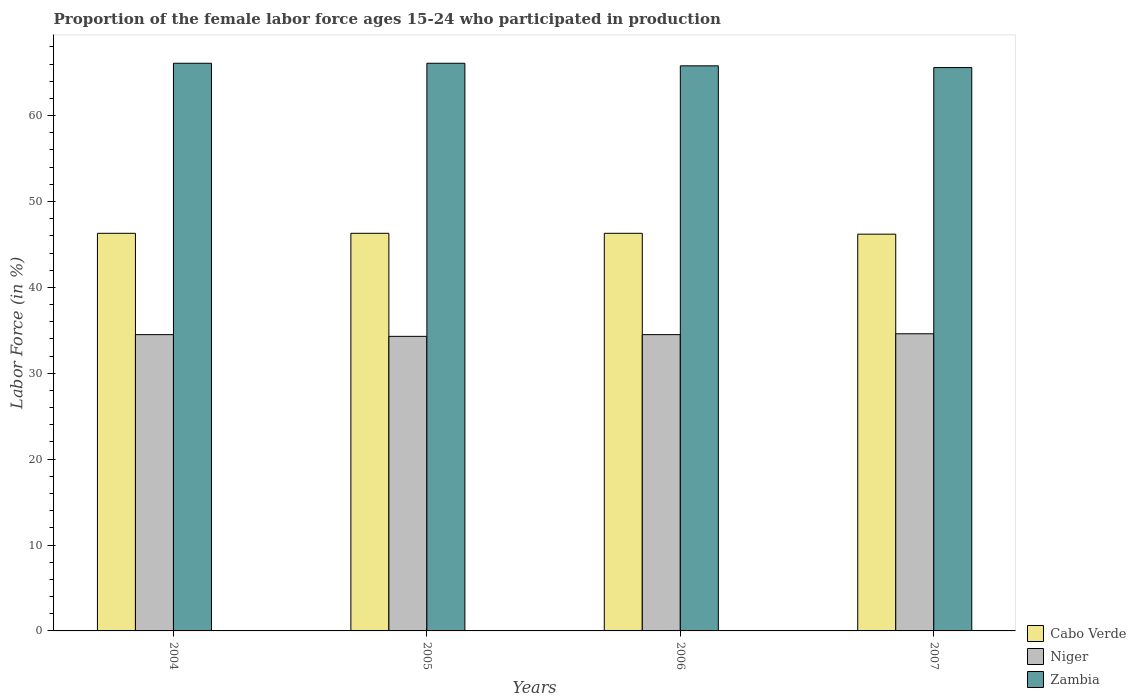How many groups of bars are there?
Ensure brevity in your answer.  4. Are the number of bars per tick equal to the number of legend labels?
Make the answer very short. Yes. Are the number of bars on each tick of the X-axis equal?
Offer a terse response. Yes. How many bars are there on the 2nd tick from the left?
Make the answer very short. 3. What is the label of the 4th group of bars from the left?
Ensure brevity in your answer.  2007. What is the proportion of the female labor force who participated in production in Cabo Verde in 2004?
Your response must be concise. 46.3. Across all years, what is the maximum proportion of the female labor force who participated in production in Niger?
Ensure brevity in your answer.  34.6. Across all years, what is the minimum proportion of the female labor force who participated in production in Niger?
Ensure brevity in your answer.  34.3. What is the total proportion of the female labor force who participated in production in Cabo Verde in the graph?
Offer a terse response. 185.1. What is the difference between the proportion of the female labor force who participated in production in Cabo Verde in 2006 and the proportion of the female labor force who participated in production in Niger in 2004?
Ensure brevity in your answer.  11.8. What is the average proportion of the female labor force who participated in production in Niger per year?
Provide a succinct answer. 34.47. In the year 2006, what is the difference between the proportion of the female labor force who participated in production in Cabo Verde and proportion of the female labor force who participated in production in Zambia?
Make the answer very short. -19.5. What is the difference between the highest and the second highest proportion of the female labor force who participated in production in Zambia?
Keep it short and to the point. 0. What is the difference between the highest and the lowest proportion of the female labor force who participated in production in Zambia?
Provide a succinct answer. 0.5. In how many years, is the proportion of the female labor force who participated in production in Zambia greater than the average proportion of the female labor force who participated in production in Zambia taken over all years?
Offer a very short reply. 2. Is the sum of the proportion of the female labor force who participated in production in Zambia in 2005 and 2007 greater than the maximum proportion of the female labor force who participated in production in Cabo Verde across all years?
Give a very brief answer. Yes. What does the 3rd bar from the left in 2005 represents?
Your answer should be compact. Zambia. What does the 3rd bar from the right in 2005 represents?
Ensure brevity in your answer.  Cabo Verde. Is it the case that in every year, the sum of the proportion of the female labor force who participated in production in Cabo Verde and proportion of the female labor force who participated in production in Niger is greater than the proportion of the female labor force who participated in production in Zambia?
Your response must be concise. Yes. How many bars are there?
Offer a terse response. 12. Are all the bars in the graph horizontal?
Your response must be concise. No. How many years are there in the graph?
Your answer should be compact. 4. Are the values on the major ticks of Y-axis written in scientific E-notation?
Ensure brevity in your answer.  No. Does the graph contain grids?
Your response must be concise. No. How are the legend labels stacked?
Give a very brief answer. Vertical. What is the title of the graph?
Offer a terse response. Proportion of the female labor force ages 15-24 who participated in production. What is the Labor Force (in %) of Cabo Verde in 2004?
Your response must be concise. 46.3. What is the Labor Force (in %) of Niger in 2004?
Make the answer very short. 34.5. What is the Labor Force (in %) in Zambia in 2004?
Ensure brevity in your answer.  66.1. What is the Labor Force (in %) of Cabo Verde in 2005?
Make the answer very short. 46.3. What is the Labor Force (in %) in Niger in 2005?
Make the answer very short. 34.3. What is the Labor Force (in %) of Zambia in 2005?
Provide a succinct answer. 66.1. What is the Labor Force (in %) in Cabo Verde in 2006?
Offer a very short reply. 46.3. What is the Labor Force (in %) of Niger in 2006?
Provide a succinct answer. 34.5. What is the Labor Force (in %) in Zambia in 2006?
Offer a terse response. 65.8. What is the Labor Force (in %) of Cabo Verde in 2007?
Offer a terse response. 46.2. What is the Labor Force (in %) in Niger in 2007?
Make the answer very short. 34.6. What is the Labor Force (in %) in Zambia in 2007?
Provide a succinct answer. 65.6. Across all years, what is the maximum Labor Force (in %) of Cabo Verde?
Make the answer very short. 46.3. Across all years, what is the maximum Labor Force (in %) in Niger?
Give a very brief answer. 34.6. Across all years, what is the maximum Labor Force (in %) of Zambia?
Provide a short and direct response. 66.1. Across all years, what is the minimum Labor Force (in %) of Cabo Verde?
Your response must be concise. 46.2. Across all years, what is the minimum Labor Force (in %) in Niger?
Your answer should be very brief. 34.3. Across all years, what is the minimum Labor Force (in %) in Zambia?
Your answer should be compact. 65.6. What is the total Labor Force (in %) in Cabo Verde in the graph?
Keep it short and to the point. 185.1. What is the total Labor Force (in %) of Niger in the graph?
Provide a succinct answer. 137.9. What is the total Labor Force (in %) in Zambia in the graph?
Provide a short and direct response. 263.6. What is the difference between the Labor Force (in %) of Zambia in 2004 and that in 2005?
Offer a terse response. 0. What is the difference between the Labor Force (in %) of Cabo Verde in 2004 and that in 2006?
Keep it short and to the point. 0. What is the difference between the Labor Force (in %) in Zambia in 2004 and that in 2006?
Your response must be concise. 0.3. What is the difference between the Labor Force (in %) of Cabo Verde in 2004 and that in 2007?
Offer a terse response. 0.1. What is the difference between the Labor Force (in %) in Niger in 2004 and that in 2007?
Your answer should be very brief. -0.1. What is the difference between the Labor Force (in %) of Zambia in 2004 and that in 2007?
Keep it short and to the point. 0.5. What is the difference between the Labor Force (in %) of Cabo Verde in 2005 and that in 2006?
Offer a very short reply. 0. What is the difference between the Labor Force (in %) of Niger in 2005 and that in 2006?
Make the answer very short. -0.2. What is the difference between the Labor Force (in %) in Cabo Verde in 2005 and that in 2007?
Your answer should be very brief. 0.1. What is the difference between the Labor Force (in %) in Zambia in 2006 and that in 2007?
Offer a very short reply. 0.2. What is the difference between the Labor Force (in %) in Cabo Verde in 2004 and the Labor Force (in %) in Niger in 2005?
Keep it short and to the point. 12. What is the difference between the Labor Force (in %) of Cabo Verde in 2004 and the Labor Force (in %) of Zambia in 2005?
Offer a very short reply. -19.8. What is the difference between the Labor Force (in %) in Niger in 2004 and the Labor Force (in %) in Zambia in 2005?
Give a very brief answer. -31.6. What is the difference between the Labor Force (in %) in Cabo Verde in 2004 and the Labor Force (in %) in Niger in 2006?
Your answer should be very brief. 11.8. What is the difference between the Labor Force (in %) in Cabo Verde in 2004 and the Labor Force (in %) in Zambia in 2006?
Provide a short and direct response. -19.5. What is the difference between the Labor Force (in %) of Niger in 2004 and the Labor Force (in %) of Zambia in 2006?
Keep it short and to the point. -31.3. What is the difference between the Labor Force (in %) in Cabo Verde in 2004 and the Labor Force (in %) in Zambia in 2007?
Your response must be concise. -19.3. What is the difference between the Labor Force (in %) in Niger in 2004 and the Labor Force (in %) in Zambia in 2007?
Offer a very short reply. -31.1. What is the difference between the Labor Force (in %) in Cabo Verde in 2005 and the Labor Force (in %) in Zambia in 2006?
Offer a terse response. -19.5. What is the difference between the Labor Force (in %) of Niger in 2005 and the Labor Force (in %) of Zambia in 2006?
Give a very brief answer. -31.5. What is the difference between the Labor Force (in %) of Cabo Verde in 2005 and the Labor Force (in %) of Zambia in 2007?
Give a very brief answer. -19.3. What is the difference between the Labor Force (in %) in Niger in 2005 and the Labor Force (in %) in Zambia in 2007?
Make the answer very short. -31.3. What is the difference between the Labor Force (in %) in Cabo Verde in 2006 and the Labor Force (in %) in Niger in 2007?
Give a very brief answer. 11.7. What is the difference between the Labor Force (in %) of Cabo Verde in 2006 and the Labor Force (in %) of Zambia in 2007?
Your answer should be compact. -19.3. What is the difference between the Labor Force (in %) in Niger in 2006 and the Labor Force (in %) in Zambia in 2007?
Keep it short and to the point. -31.1. What is the average Labor Force (in %) of Cabo Verde per year?
Your response must be concise. 46.27. What is the average Labor Force (in %) of Niger per year?
Your answer should be very brief. 34.48. What is the average Labor Force (in %) of Zambia per year?
Your answer should be compact. 65.9. In the year 2004, what is the difference between the Labor Force (in %) in Cabo Verde and Labor Force (in %) in Niger?
Give a very brief answer. 11.8. In the year 2004, what is the difference between the Labor Force (in %) in Cabo Verde and Labor Force (in %) in Zambia?
Provide a short and direct response. -19.8. In the year 2004, what is the difference between the Labor Force (in %) in Niger and Labor Force (in %) in Zambia?
Offer a terse response. -31.6. In the year 2005, what is the difference between the Labor Force (in %) of Cabo Verde and Labor Force (in %) of Zambia?
Your response must be concise. -19.8. In the year 2005, what is the difference between the Labor Force (in %) in Niger and Labor Force (in %) in Zambia?
Offer a very short reply. -31.8. In the year 2006, what is the difference between the Labor Force (in %) of Cabo Verde and Labor Force (in %) of Niger?
Make the answer very short. 11.8. In the year 2006, what is the difference between the Labor Force (in %) of Cabo Verde and Labor Force (in %) of Zambia?
Provide a succinct answer. -19.5. In the year 2006, what is the difference between the Labor Force (in %) of Niger and Labor Force (in %) of Zambia?
Provide a short and direct response. -31.3. In the year 2007, what is the difference between the Labor Force (in %) in Cabo Verde and Labor Force (in %) in Niger?
Your answer should be very brief. 11.6. In the year 2007, what is the difference between the Labor Force (in %) of Cabo Verde and Labor Force (in %) of Zambia?
Make the answer very short. -19.4. In the year 2007, what is the difference between the Labor Force (in %) of Niger and Labor Force (in %) of Zambia?
Give a very brief answer. -31. What is the ratio of the Labor Force (in %) of Cabo Verde in 2004 to that in 2005?
Offer a terse response. 1. What is the ratio of the Labor Force (in %) of Zambia in 2004 to that in 2005?
Ensure brevity in your answer.  1. What is the ratio of the Labor Force (in %) in Cabo Verde in 2004 to that in 2006?
Offer a very short reply. 1. What is the ratio of the Labor Force (in %) in Zambia in 2004 to that in 2006?
Offer a terse response. 1. What is the ratio of the Labor Force (in %) of Cabo Verde in 2004 to that in 2007?
Ensure brevity in your answer.  1. What is the ratio of the Labor Force (in %) in Zambia in 2004 to that in 2007?
Your answer should be compact. 1.01. What is the ratio of the Labor Force (in %) of Niger in 2005 to that in 2007?
Provide a short and direct response. 0.99. What is the ratio of the Labor Force (in %) of Zambia in 2005 to that in 2007?
Your answer should be compact. 1.01. What is the ratio of the Labor Force (in %) in Niger in 2006 to that in 2007?
Provide a short and direct response. 1. What is the difference between the highest and the second highest Labor Force (in %) of Cabo Verde?
Ensure brevity in your answer.  0. What is the difference between the highest and the second highest Labor Force (in %) of Zambia?
Provide a succinct answer. 0. What is the difference between the highest and the lowest Labor Force (in %) of Cabo Verde?
Your answer should be very brief. 0.1. What is the difference between the highest and the lowest Labor Force (in %) in Niger?
Your response must be concise. 0.3. What is the difference between the highest and the lowest Labor Force (in %) in Zambia?
Offer a terse response. 0.5. 